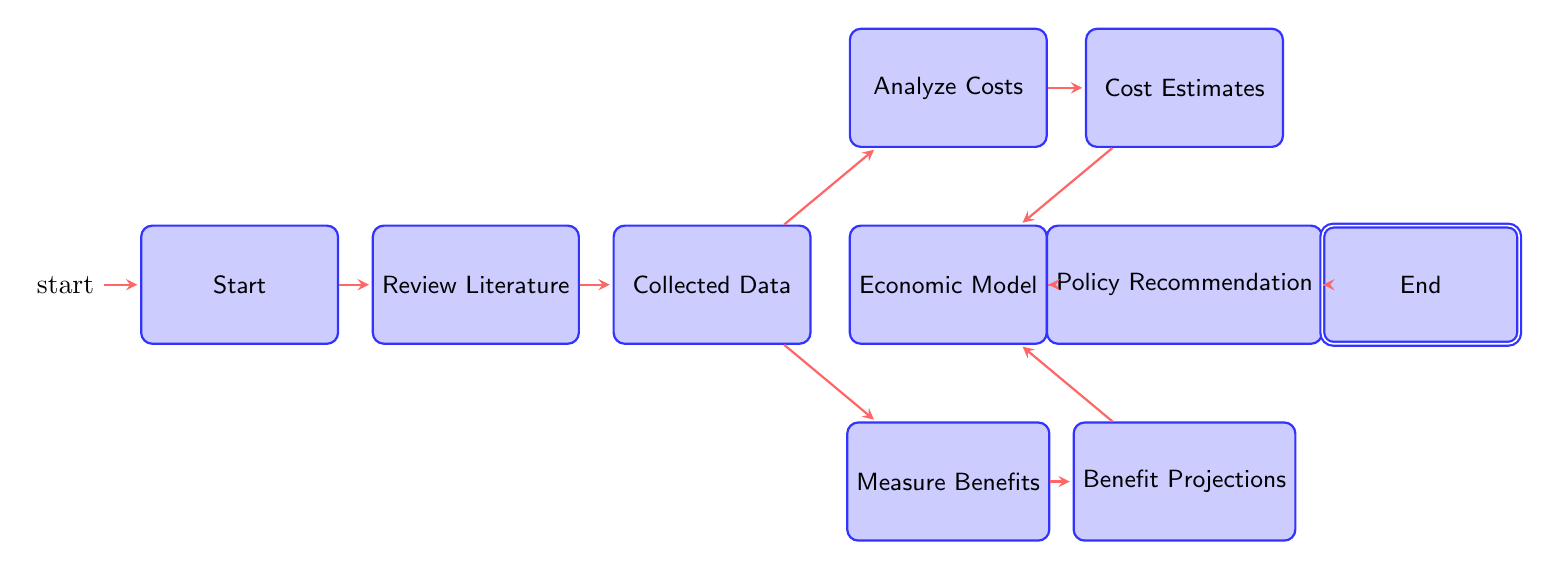What is the initial state of the diagram? The diagram begins at the "Start" state, which is the first node that indicates the analysis has not yet begun.
Answer: Start How many states are present in the diagram? The diagram includes a total of 10 states, each representing a distinct step or phase in the analysis process.
Answer: 10 What are the outputs of the "Collected_Data" state? From the "Collected_Data" state, there are two outputs: "Analyze_Costs" and "Measure_Benefits." This indicates the next steps that can be taken after data is collected.
Answer: Analyze_Costs, Measure_Benefits Which state comes after "Policy_Recommendation"? Following "Policy_Recommendation," the next state in the diagram is "End," indicating completion of the analysis and recommendations.
Answer: End What transition occurs after "Review_Literature"? After the "Review_Literature" state, the transition leads to the "Collected_Data" state, indicating the progression from reviewing literature to gathering data.
Answer: Collected_Data Which states are integrated into the "Economic_Model"? The "Economic_Model" state integrates outputs from "Cost_Estimates" and "Benefit_Projections," combining both costs and benefits into a comprehensive economic model.
Answer: Cost_Estimates, Benefit_Projections What is the last stage of the analysis? The last stage of the analysis, as indicated in the diagram, is the "End" state, which signifies that the entire evaluation process and recommendations have been completed.
Answer: End What two evaluation aspects are assessed after collecting data? After "Collected_Data," the two evaluations that are assessed are "Analyze_Costs" and "Measure_Benefits," representing a dual focus on both costs associated with ECE programs and their benefits.
Answer: Analyze_Costs, Measure_Benefits Which nodes represent the cost-related processes? The nodes that represent the cost-related processes are "Analyze_Costs," "Cost_Estimates," and "Economic_Model," forming a pathway to assess and model costs related to ECE investment.
Answer: Analyze_Costs, Cost_Estimates, Economic_Model 